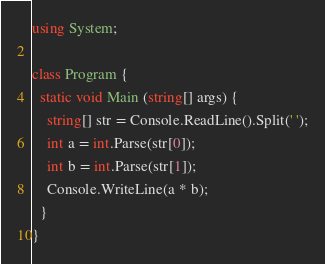Convert code to text. <code><loc_0><loc_0><loc_500><loc_500><_C#_>using System;

class Program {
  static void Main (string[] args) {
    string[] str = Console.ReadLine().Split(' ');
    int a = int.Parse(str[0]);
    int b = int.Parse(str[1]);
    Console.WriteLine(a * b);
  }
}</code> 